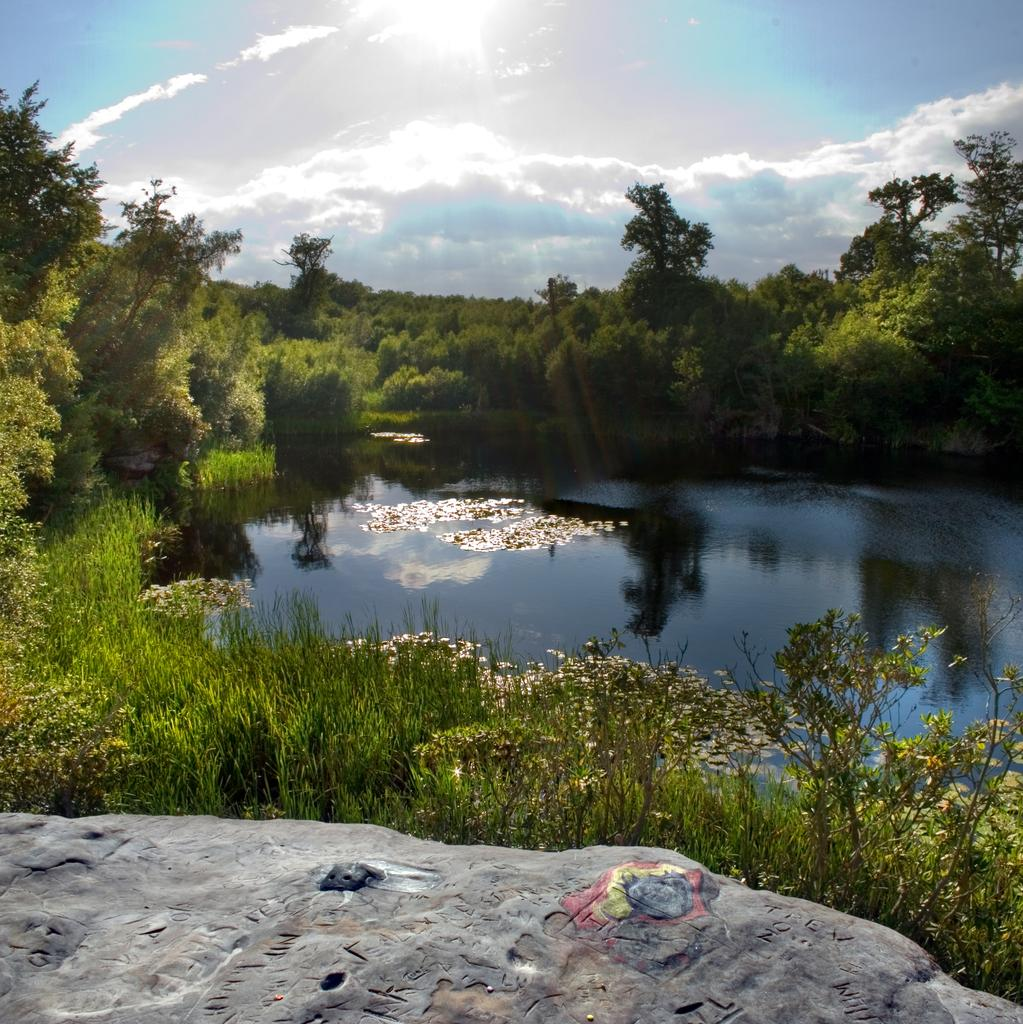What type of natural elements can be seen in the image? There are trees and plants in the image. What body of water is present in the image? There is a lake in the middle of the image. What geological feature can be found at the bottom of the image? There is a rock at the bottom of the image. What is visible at the top of the image? The sky is visible at the top of the image. What type of toad can be seen swimming in the lake in the image? There is no toad present in the image; it only features trees, plants, a lake, a rock, and the sky. 